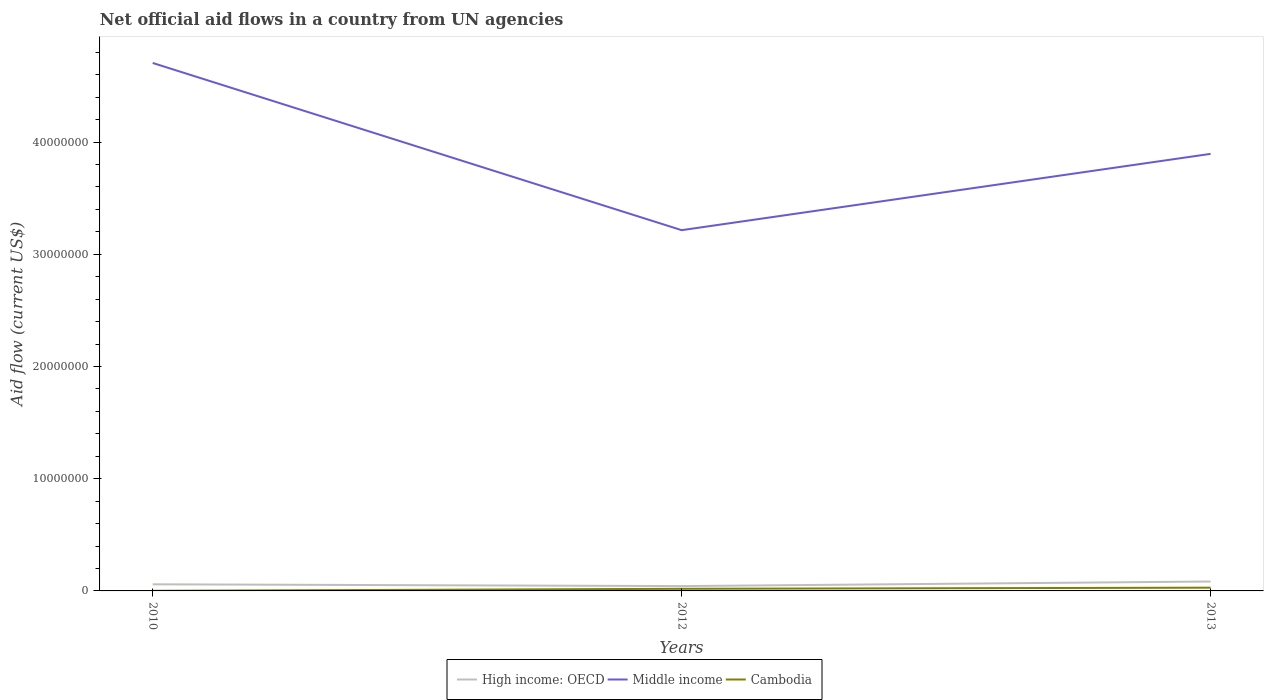Across all years, what is the maximum net official aid flow in High income: OECD?
Ensure brevity in your answer.  4.30e+05. In which year was the net official aid flow in Cambodia maximum?
Your response must be concise. 2010. What is the total net official aid flow in High income: OECD in the graph?
Offer a very short reply. 1.60e+05. What is the difference between the highest and the second highest net official aid flow in Middle income?
Offer a very short reply. 1.49e+07. How many lines are there?
Ensure brevity in your answer.  3. How many years are there in the graph?
Make the answer very short. 3. What is the difference between two consecutive major ticks on the Y-axis?
Ensure brevity in your answer.  1.00e+07. Does the graph contain any zero values?
Your answer should be compact. No. Does the graph contain grids?
Your answer should be compact. No. Where does the legend appear in the graph?
Ensure brevity in your answer.  Bottom center. How many legend labels are there?
Provide a succinct answer. 3. How are the legend labels stacked?
Keep it short and to the point. Horizontal. What is the title of the graph?
Your answer should be compact. Net official aid flows in a country from UN agencies. What is the Aid flow (current US$) of High income: OECD in 2010?
Provide a short and direct response. 5.90e+05. What is the Aid flow (current US$) in Middle income in 2010?
Provide a succinct answer. 4.70e+07. What is the Aid flow (current US$) in Cambodia in 2010?
Offer a very short reply. 10000. What is the Aid flow (current US$) in High income: OECD in 2012?
Give a very brief answer. 4.30e+05. What is the Aid flow (current US$) in Middle income in 2012?
Keep it short and to the point. 3.22e+07. What is the Aid flow (current US$) in High income: OECD in 2013?
Give a very brief answer. 8.40e+05. What is the Aid flow (current US$) in Middle income in 2013?
Provide a succinct answer. 3.90e+07. What is the Aid flow (current US$) of Cambodia in 2013?
Ensure brevity in your answer.  2.90e+05. Across all years, what is the maximum Aid flow (current US$) in High income: OECD?
Give a very brief answer. 8.40e+05. Across all years, what is the maximum Aid flow (current US$) of Middle income?
Keep it short and to the point. 4.70e+07. Across all years, what is the minimum Aid flow (current US$) in Middle income?
Offer a very short reply. 3.22e+07. Across all years, what is the minimum Aid flow (current US$) of Cambodia?
Give a very brief answer. 10000. What is the total Aid flow (current US$) of High income: OECD in the graph?
Provide a short and direct response. 1.86e+06. What is the total Aid flow (current US$) in Middle income in the graph?
Your response must be concise. 1.18e+08. What is the total Aid flow (current US$) of Cambodia in the graph?
Provide a succinct answer. 4.90e+05. What is the difference between the Aid flow (current US$) in Middle income in 2010 and that in 2012?
Your response must be concise. 1.49e+07. What is the difference between the Aid flow (current US$) of Middle income in 2010 and that in 2013?
Provide a succinct answer. 8.10e+06. What is the difference between the Aid flow (current US$) in Cambodia in 2010 and that in 2013?
Ensure brevity in your answer.  -2.80e+05. What is the difference between the Aid flow (current US$) in High income: OECD in 2012 and that in 2013?
Make the answer very short. -4.10e+05. What is the difference between the Aid flow (current US$) in Middle income in 2012 and that in 2013?
Your answer should be very brief. -6.80e+06. What is the difference between the Aid flow (current US$) in High income: OECD in 2010 and the Aid flow (current US$) in Middle income in 2012?
Make the answer very short. -3.16e+07. What is the difference between the Aid flow (current US$) of Middle income in 2010 and the Aid flow (current US$) of Cambodia in 2012?
Keep it short and to the point. 4.69e+07. What is the difference between the Aid flow (current US$) of High income: OECD in 2010 and the Aid flow (current US$) of Middle income in 2013?
Your answer should be compact. -3.84e+07. What is the difference between the Aid flow (current US$) of High income: OECD in 2010 and the Aid flow (current US$) of Cambodia in 2013?
Your answer should be very brief. 3.00e+05. What is the difference between the Aid flow (current US$) of Middle income in 2010 and the Aid flow (current US$) of Cambodia in 2013?
Your answer should be very brief. 4.68e+07. What is the difference between the Aid flow (current US$) of High income: OECD in 2012 and the Aid flow (current US$) of Middle income in 2013?
Give a very brief answer. -3.85e+07. What is the difference between the Aid flow (current US$) in High income: OECD in 2012 and the Aid flow (current US$) in Cambodia in 2013?
Your answer should be compact. 1.40e+05. What is the difference between the Aid flow (current US$) of Middle income in 2012 and the Aid flow (current US$) of Cambodia in 2013?
Keep it short and to the point. 3.19e+07. What is the average Aid flow (current US$) of High income: OECD per year?
Your response must be concise. 6.20e+05. What is the average Aid flow (current US$) in Middle income per year?
Keep it short and to the point. 3.94e+07. What is the average Aid flow (current US$) in Cambodia per year?
Provide a short and direct response. 1.63e+05. In the year 2010, what is the difference between the Aid flow (current US$) of High income: OECD and Aid flow (current US$) of Middle income?
Your response must be concise. -4.65e+07. In the year 2010, what is the difference between the Aid flow (current US$) in High income: OECD and Aid flow (current US$) in Cambodia?
Your answer should be very brief. 5.80e+05. In the year 2010, what is the difference between the Aid flow (current US$) in Middle income and Aid flow (current US$) in Cambodia?
Your answer should be very brief. 4.70e+07. In the year 2012, what is the difference between the Aid flow (current US$) of High income: OECD and Aid flow (current US$) of Middle income?
Give a very brief answer. -3.17e+07. In the year 2012, what is the difference between the Aid flow (current US$) of High income: OECD and Aid flow (current US$) of Cambodia?
Keep it short and to the point. 2.40e+05. In the year 2012, what is the difference between the Aid flow (current US$) in Middle income and Aid flow (current US$) in Cambodia?
Your answer should be compact. 3.20e+07. In the year 2013, what is the difference between the Aid flow (current US$) in High income: OECD and Aid flow (current US$) in Middle income?
Make the answer very short. -3.81e+07. In the year 2013, what is the difference between the Aid flow (current US$) of Middle income and Aid flow (current US$) of Cambodia?
Your answer should be compact. 3.87e+07. What is the ratio of the Aid flow (current US$) in High income: OECD in 2010 to that in 2012?
Your answer should be very brief. 1.37. What is the ratio of the Aid flow (current US$) of Middle income in 2010 to that in 2012?
Offer a very short reply. 1.46. What is the ratio of the Aid flow (current US$) in Cambodia in 2010 to that in 2012?
Provide a short and direct response. 0.05. What is the ratio of the Aid flow (current US$) of High income: OECD in 2010 to that in 2013?
Your answer should be very brief. 0.7. What is the ratio of the Aid flow (current US$) in Middle income in 2010 to that in 2013?
Your answer should be compact. 1.21. What is the ratio of the Aid flow (current US$) in Cambodia in 2010 to that in 2013?
Provide a succinct answer. 0.03. What is the ratio of the Aid flow (current US$) of High income: OECD in 2012 to that in 2013?
Your response must be concise. 0.51. What is the ratio of the Aid flow (current US$) in Middle income in 2012 to that in 2013?
Your answer should be compact. 0.83. What is the ratio of the Aid flow (current US$) in Cambodia in 2012 to that in 2013?
Your answer should be very brief. 0.66. What is the difference between the highest and the second highest Aid flow (current US$) in Middle income?
Offer a very short reply. 8.10e+06. What is the difference between the highest and the lowest Aid flow (current US$) of High income: OECD?
Your response must be concise. 4.10e+05. What is the difference between the highest and the lowest Aid flow (current US$) of Middle income?
Your response must be concise. 1.49e+07. 